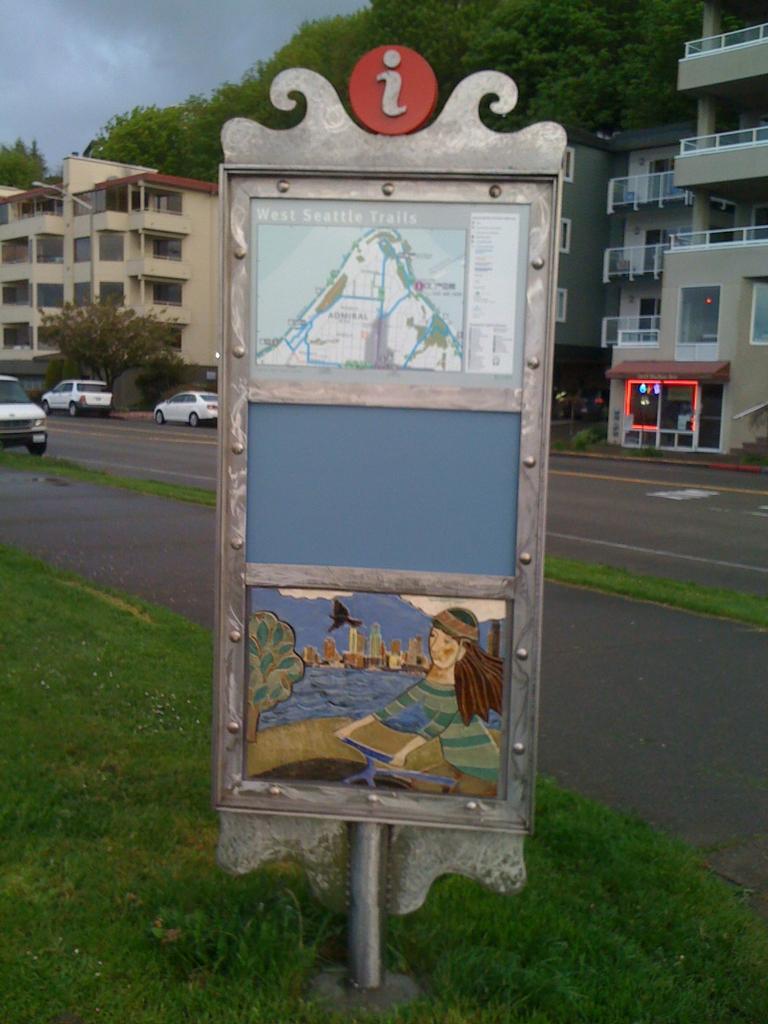How would you summarize this image in a sentence or two? In this image I can see a board in the front. There is grass on the left. There are cars on the road. There are buildings and trees at the back. There is sky at the top. 